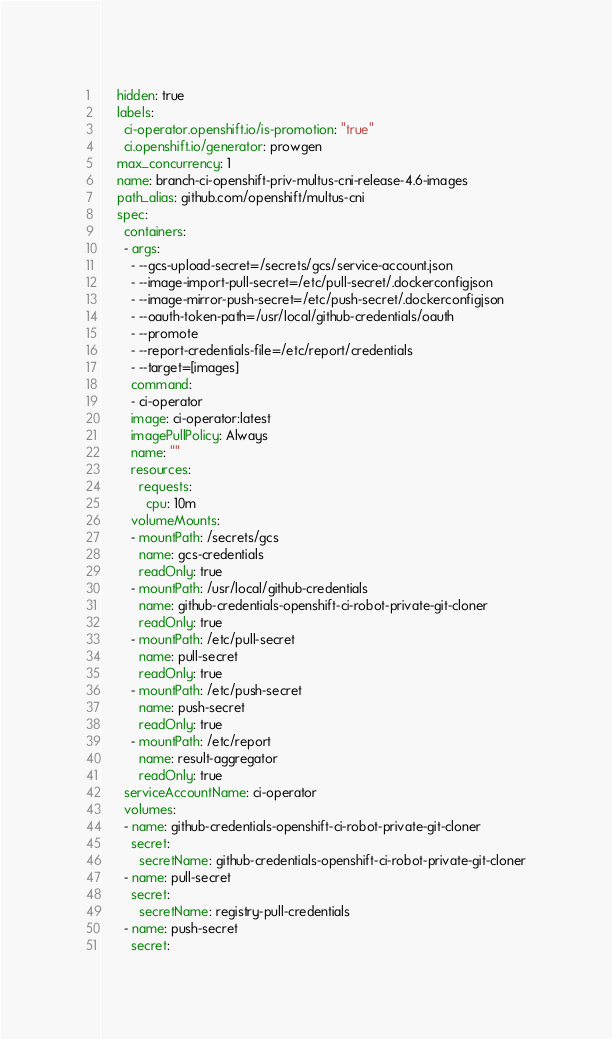<code> <loc_0><loc_0><loc_500><loc_500><_YAML_>    hidden: true
    labels:
      ci-operator.openshift.io/is-promotion: "true"
      ci.openshift.io/generator: prowgen
    max_concurrency: 1
    name: branch-ci-openshift-priv-multus-cni-release-4.6-images
    path_alias: github.com/openshift/multus-cni
    spec:
      containers:
      - args:
        - --gcs-upload-secret=/secrets/gcs/service-account.json
        - --image-import-pull-secret=/etc/pull-secret/.dockerconfigjson
        - --image-mirror-push-secret=/etc/push-secret/.dockerconfigjson
        - --oauth-token-path=/usr/local/github-credentials/oauth
        - --promote
        - --report-credentials-file=/etc/report/credentials
        - --target=[images]
        command:
        - ci-operator
        image: ci-operator:latest
        imagePullPolicy: Always
        name: ""
        resources:
          requests:
            cpu: 10m
        volumeMounts:
        - mountPath: /secrets/gcs
          name: gcs-credentials
          readOnly: true
        - mountPath: /usr/local/github-credentials
          name: github-credentials-openshift-ci-robot-private-git-cloner
          readOnly: true
        - mountPath: /etc/pull-secret
          name: pull-secret
          readOnly: true
        - mountPath: /etc/push-secret
          name: push-secret
          readOnly: true
        - mountPath: /etc/report
          name: result-aggregator
          readOnly: true
      serviceAccountName: ci-operator
      volumes:
      - name: github-credentials-openshift-ci-robot-private-git-cloner
        secret:
          secretName: github-credentials-openshift-ci-robot-private-git-cloner
      - name: pull-secret
        secret:
          secretName: registry-pull-credentials
      - name: push-secret
        secret:</code> 